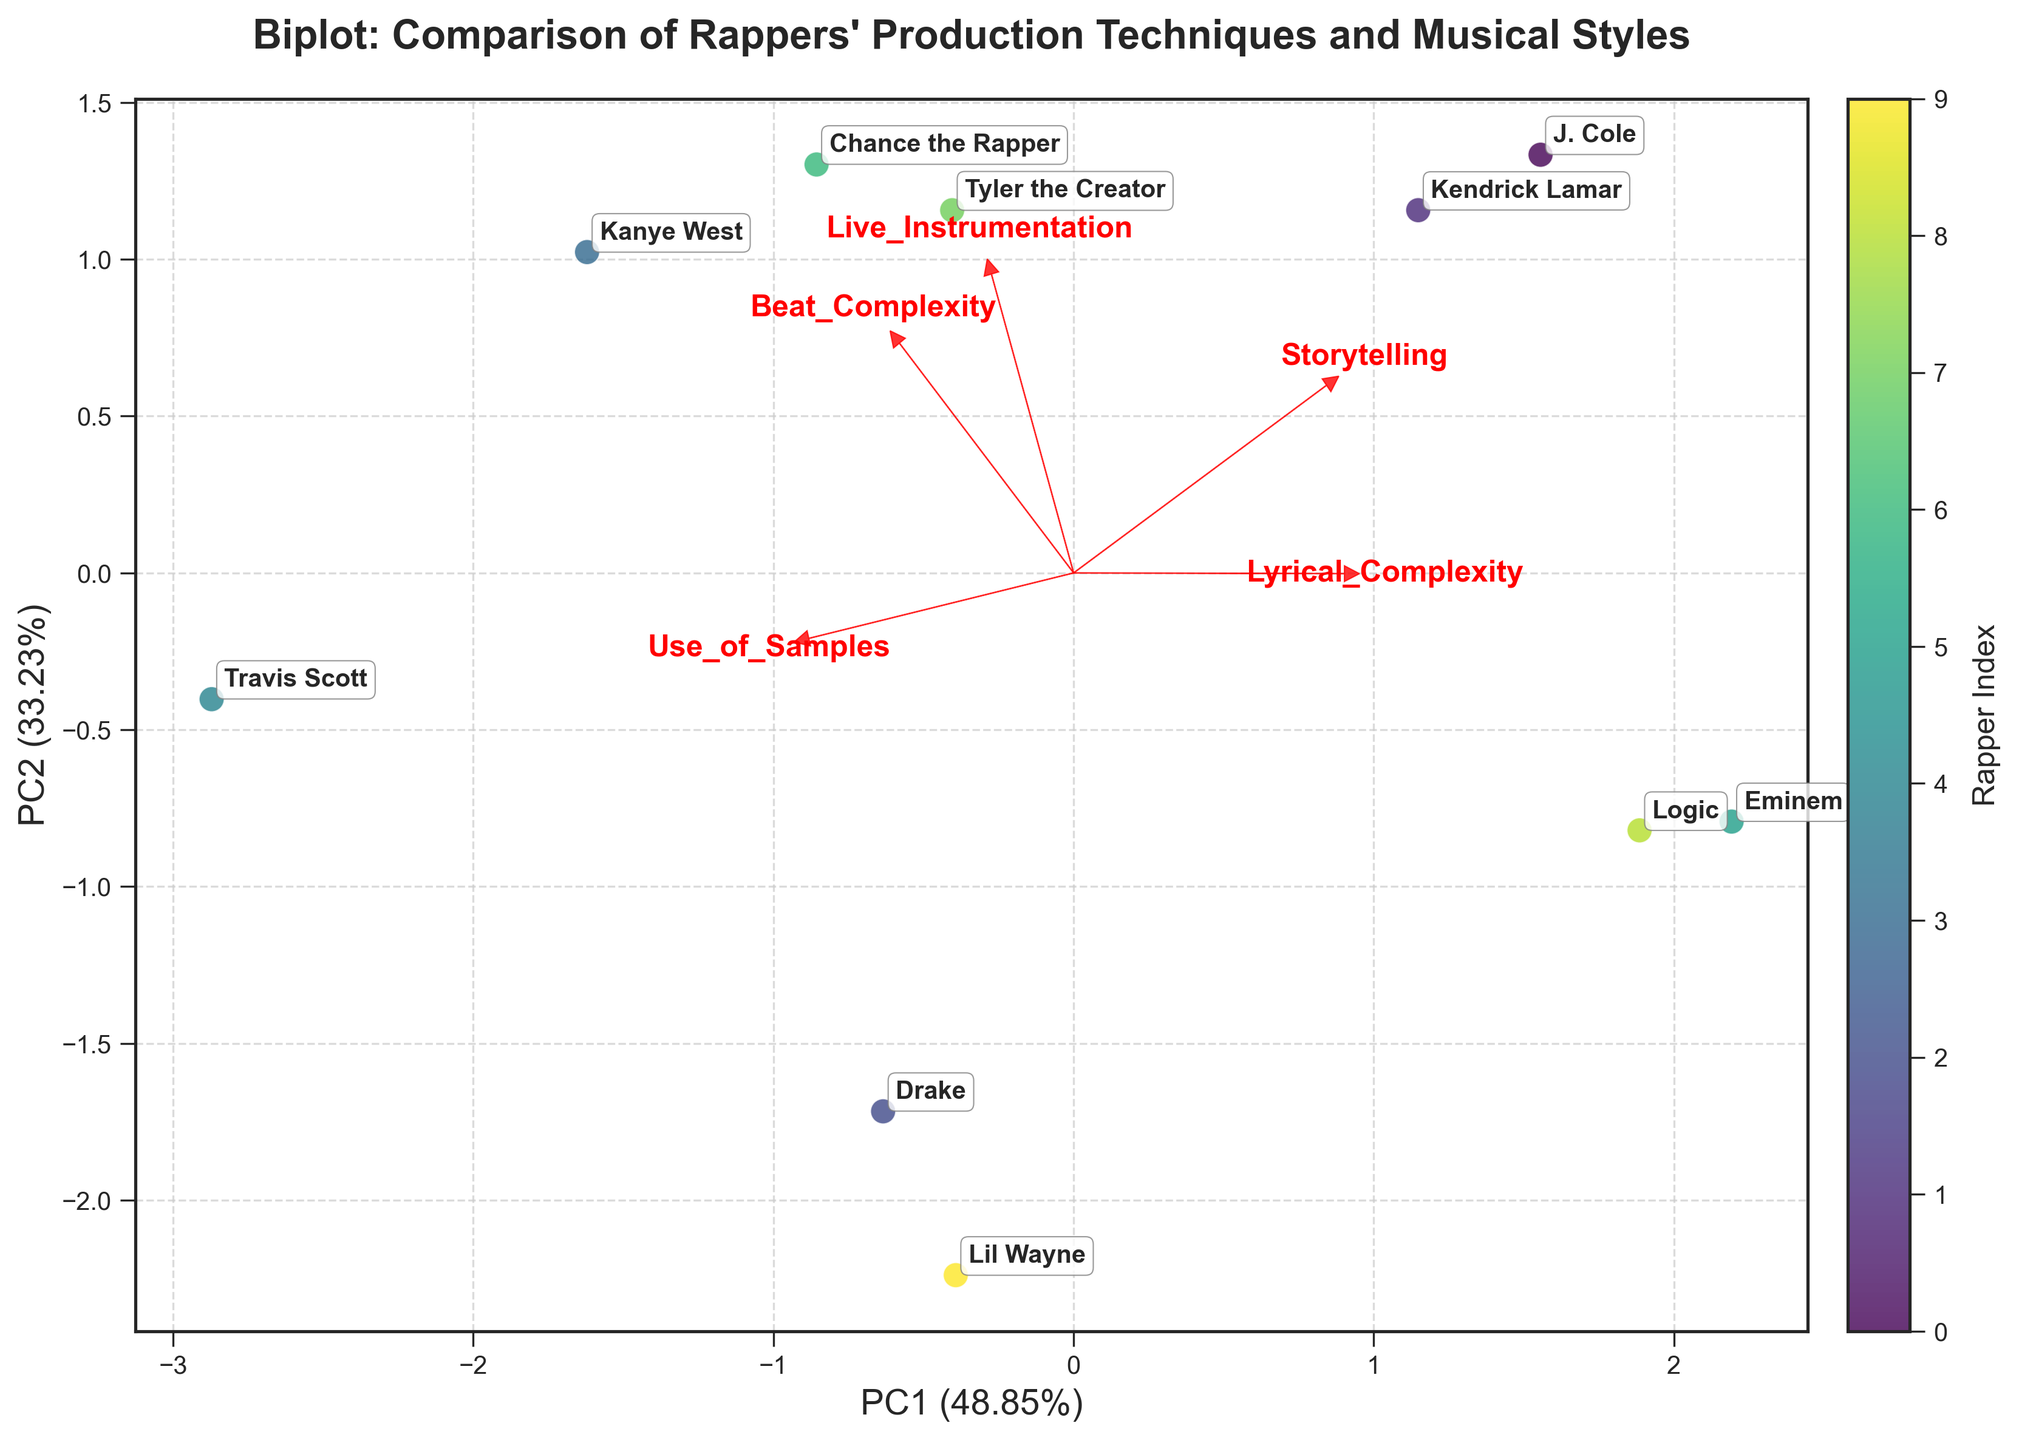What does the title of the biplot say? The title can be found at the top of the figure. By reading it directly, it indicates the main subject of the biplot.
Answer: "Biplot: Comparison of Rappers' Production Techniques and Musical Styles" How are the axes labeled in the biplot? The x-axis and y-axis labels are directly visible on the plot. They indicate the first and second principal components (PC1 and PC2) along with the percentage of variance explained by each principal component.
Answer: PC1 and PC2 with their respective variance percentages Which rappers are closest to each other in the biplot? By visually inspecting the relative positions of the points labeled with rappers' names, you can identify which points are closest.
Answer: J. Cole and Lil Wayne Which feature has the longest vector in the biplot? The length of the vector represents the importance of the feature. By comparing the lengths of the vectors starting from the origin and pointing towards the feature names, its longest vector can be identified.
Answer: Beat_Complexity What does a longer vector in a biplot represent? In a biplot, the length of a feature vector indicates the level of importance or contribution of that feature to the principal components.
Answer: Greater importance of the feature Which rapper has the highest value in Lyrical_Complexity according to the biplot? By examining the positions of the points and the direction of the Lyrical_Complexity vector, you can infer the rapper who lies furthest along this direction.
Answer: Eminem How does J. Cole compare to Kanye West in terms of Beat_Complexity as seen in the biplot? By looking at their positions relative to the Beat_Complexity vector, one can see if J. Cole or Kanye West is positioned closer or further along this vector.
Answer: Kanye West has higher Beat_Complexity Which two features seem to contribute most to the variation among the rappers? The length of the vectors and how spread they are from the origin indicates how much they contribute to the variation seen along the principal components. The two longest vectors give the answer.
Answer: Beat_Complexity and Storytelling From the perspective of Storytelling and Live_Instrumentation, how do the rappers compare? By observing the direction and length of the Storytelling and Live_Instrumentation vectors and the rappers' points relative to these vectors, we can compare their contributions.
Answer: J. Cole and Chance the Rapper show high values in Storytelling and Live_Instrumentation Which rapper appears to balance all the features relatively well? A rapper balancing all features well would be positioned centrally in the plot, in a place that doesn't highly favor any particular vector.
Answer: Tyler the Creator 